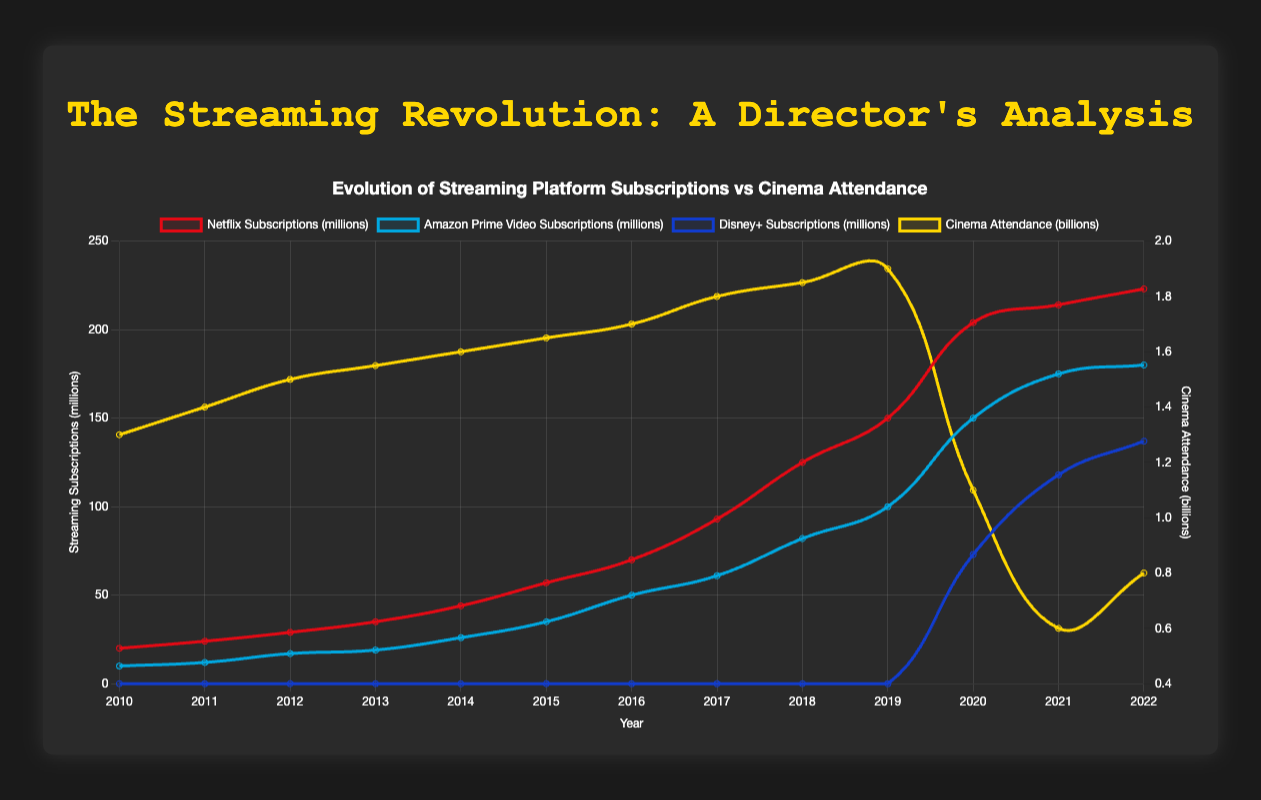What is the subscription trend for Netflix from 2010 to 2022? Netflix subscriptions have increased steadily from 20 million in 2010 to 223 million in 2022, showing a consistent upward trend over the years.
Answer: Upward trend When did Disney+ see its first significant increase in subscriptions? Disney+ shows a significant increase starting in 2020, with subscriptions jumping from 0 to 73 million.
Answer: 2020 How does the cinema attendance in 2019 compare to the Netflix subscriptions in the same year? In 2019, cinema attendance was 1.9 billion while Netflix subscriptions were 150 million. This indicates significantly higher cinema attendance when compared to Netflix subscriptions.
Answer: Cinema attendance is higher Which platform experienced the most significant growth in the year 2020? Netflix subscriptions increased from 150 million in 2019 to 204 million in 2020, while Amazon Prime Video increased from 100 million to 150 million and Disney+ from 0 to 73 million. However, Disney+ saw the most significant growth as it started from zero and reached 73 million.
Answer: Disney+ What is the trend in cinema attendance from 2010 to 2022, and how did the COVID-19 pandemic (presumably starting around 2020) affect it? Cinema attendance generally increased from 1.3 billion in 2010 to 1.9 billion in 2019 before a significant drop to 1.1 billion in 2020, likely due to the pandemic. It dropped further in 2021 to 0.6 billion, then slightly recovered to 0.8 billion in 2022, indicating the strong impact of the pandemic.
Answer: Significant drop starting in 2020 Compare the growth rates of Amazon Prime Video and Netflix between 2014 and 2019. In 2014, Amazon Prime Video had 26 million subscriptions and in 2019 it reached 100 million, a growth of 74 million. Netflix had 44 million in 2014 and 150 million in 2019, a growth of 106 million. Thus, both platforms grew, but Netflix grew more substantially.
Answer: Netflix grew more Calculate the average annual increase in Netflix subscriptions between 2010 and 2022. From 2010 to 2022, Netflix subscriptions grew from 20 million to 223 million, i.e., an increase of 203 million over 12 years. The average annual increase is 203 million divided by 12 years, approximately 16.92 million per year.
Answer: 16.92 million per year What visual cues indicate the decline in cinema attendance post-2019? The yellow line representing cinema attendance significantly dips after 2019, dropping steeply in height from 1.9 billion to 1.1 billion in 2020, indicating a decline.
Answer: Steep drop in yellow line height after 2019 Identify the year with the highest streaming platform growth overall and explain why. 2020 shows the highest overall growth with Netflix increasing by 54 million, Amazon Prime Video by 50 million, and Disney+ by 73 million, marking significant jumps for all three major platforms.
Answer: 2020 